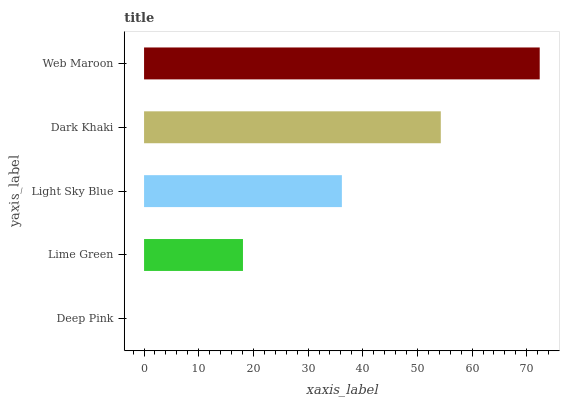Is Deep Pink the minimum?
Answer yes or no. Yes. Is Web Maroon the maximum?
Answer yes or no. Yes. Is Lime Green the minimum?
Answer yes or no. No. Is Lime Green the maximum?
Answer yes or no. No. Is Lime Green greater than Deep Pink?
Answer yes or no. Yes. Is Deep Pink less than Lime Green?
Answer yes or no. Yes. Is Deep Pink greater than Lime Green?
Answer yes or no. No. Is Lime Green less than Deep Pink?
Answer yes or no. No. Is Light Sky Blue the high median?
Answer yes or no. Yes. Is Light Sky Blue the low median?
Answer yes or no. Yes. Is Dark Khaki the high median?
Answer yes or no. No. Is Lime Green the low median?
Answer yes or no. No. 